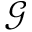<formula> <loc_0><loc_0><loc_500><loc_500>\mathcal { G }</formula> 